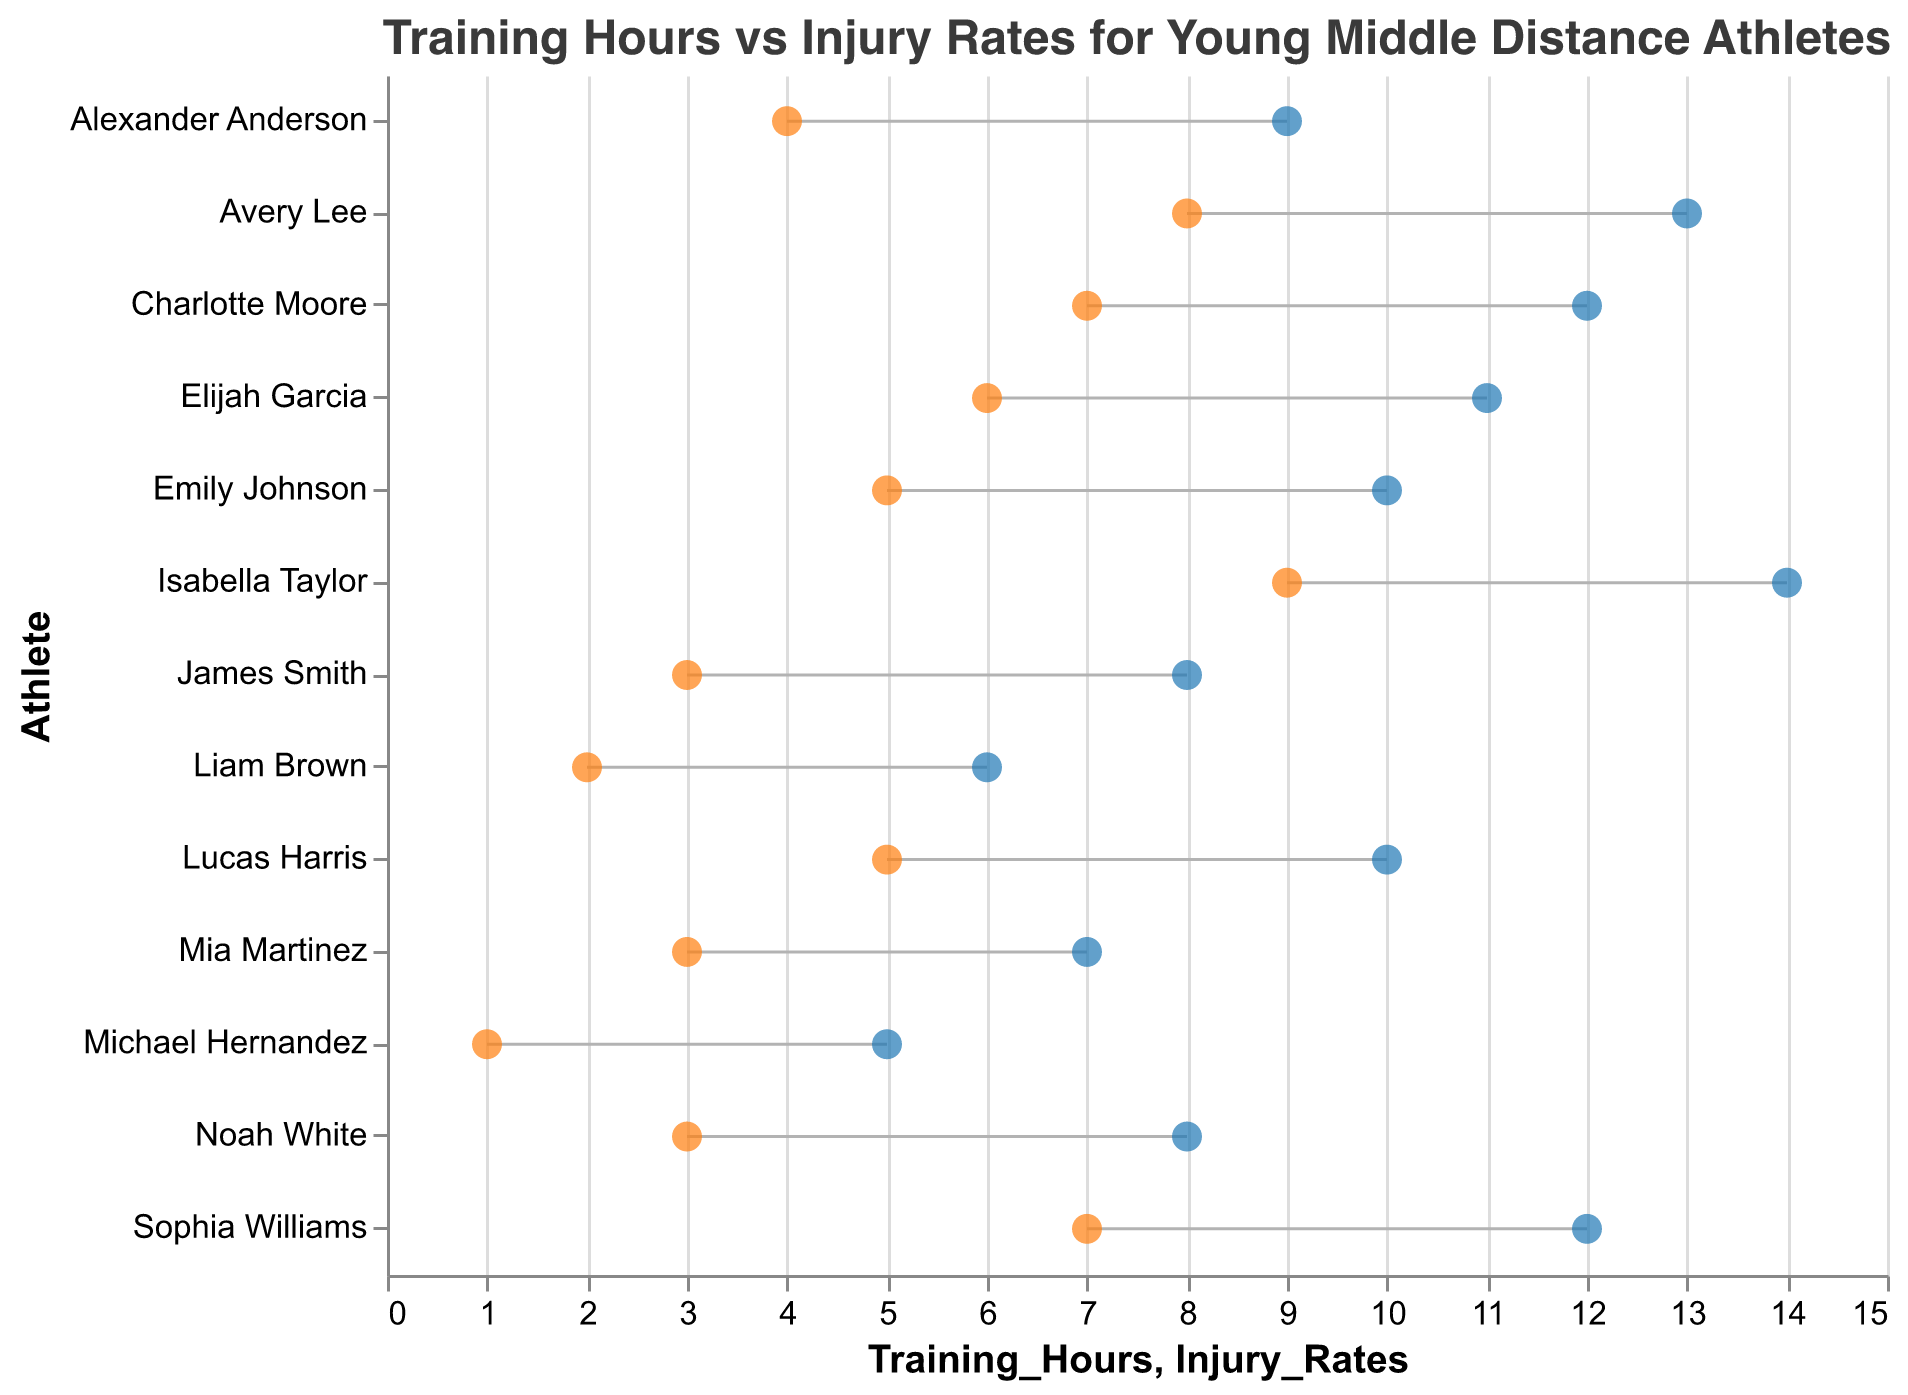What is the title of the plot? The title of the plot is displayed at the top and indicates the subject of the figure. It reads "Training Hours vs Injury Rates for Young Middle Distance Athletes".
Answer: Training Hours vs Injury Rates for Young Middle Distance Athletes How many athletes are displayed in the plot? Count the number of unique entries along the y-axis which represent individual athletes. There are 13 athletes listed.
Answer: 13 Which athlete has the highest training hours, and what is their injury rate? Locate the point farthest to the right on the Training Hours axis, which is 'Isabella Taylor' with 14 training hours. The corresponding point on the Injury Rates axis is 9.
Answer: Isabella Taylor, 9 Which two athletes have an identical training and injury rate? Find any athletes where both the Training Hours and Injury Rates values are the same. ‘James Smith’ and ‘Noah White’ both have 8 training hours and an injury rate of 3.
Answer: James Smith and Noah White What is the average training hours of all athletes? Sum up all the training hours and divide by the number of athletes. The sum is (10+8+12+6+14+9+7+11+13+5+12+8+10) = 125. Divide this by 13 (total number of athletes).
Answer: 9.62 Which athlete has the lowest injury rate, and what are their training hours? Identify the point farthest to the left on the Injury Rates axis, which is 'Michael Hernandez' with an injury rate of 1. The corresponding point on the Training Hours axis is 5.
Answer: Michael Hernandez, 5 How many athletes have a training schedule greater than 10 hours per week? Identify all points on the Training Hours axis greater than 10. These athletes are ‘Sophia Williams’, ‘Isabella Taylor’, ‘Elijah Garcia’, ‘Avery Lee’, and ‘Charlotte Moore’. Count these athletes.
Answer: 5 Which athlete has the greatest difference between training hours and injury rate, and what is that difference? Calculate the difference between the training hours and injury rate for each athlete. ‘Isabella Taylor’ has 14 training hours and 9 injury rate, difference is (14-9)=5. Other differences are less.
Answer: Isabella Taylor, 5 Is there an overall trend between training hours and injury rates according to the plot? Observe the general direction of the points from left to right among the training hours and injury rates. As training hours increase, injury rates appear to also increase, showing a positive relationship.
Answer: Positive relationship What are the training hours and injury rates for ‘Liam Brown’? Locate the data point associated with ‘Liam Brown’. The corresponding points will show 6 training hours and 2 injury rates.
Answer: 6 training hours, 2 injury rates 